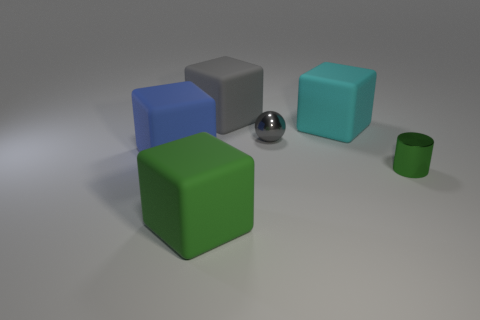Are there an equal number of large blue rubber things that are behind the small gray object and large metallic cylinders?
Offer a very short reply. Yes. Are there any purple cylinders of the same size as the cyan cube?
Keep it short and to the point. No. There is a cyan cube; is its size the same as the matte block that is behind the large cyan cube?
Your answer should be compact. Yes. Are there the same number of blue things on the right side of the big cyan cube and green cubes that are behind the green rubber thing?
Offer a very short reply. Yes. What shape is the big object that is the same color as the tiny metallic ball?
Provide a succinct answer. Cube. There is a green cube that is on the left side of the metal cylinder; what is its material?
Provide a succinct answer. Rubber. Do the green matte object and the cylinder have the same size?
Provide a short and direct response. No. Is the number of metal cylinders that are behind the big gray rubber thing greater than the number of large red metal cylinders?
Your answer should be very brief. No. What is the size of the green cube that is the same material as the blue cube?
Your response must be concise. Large. There is a small gray sphere; are there any objects to the right of it?
Your answer should be very brief. Yes. 